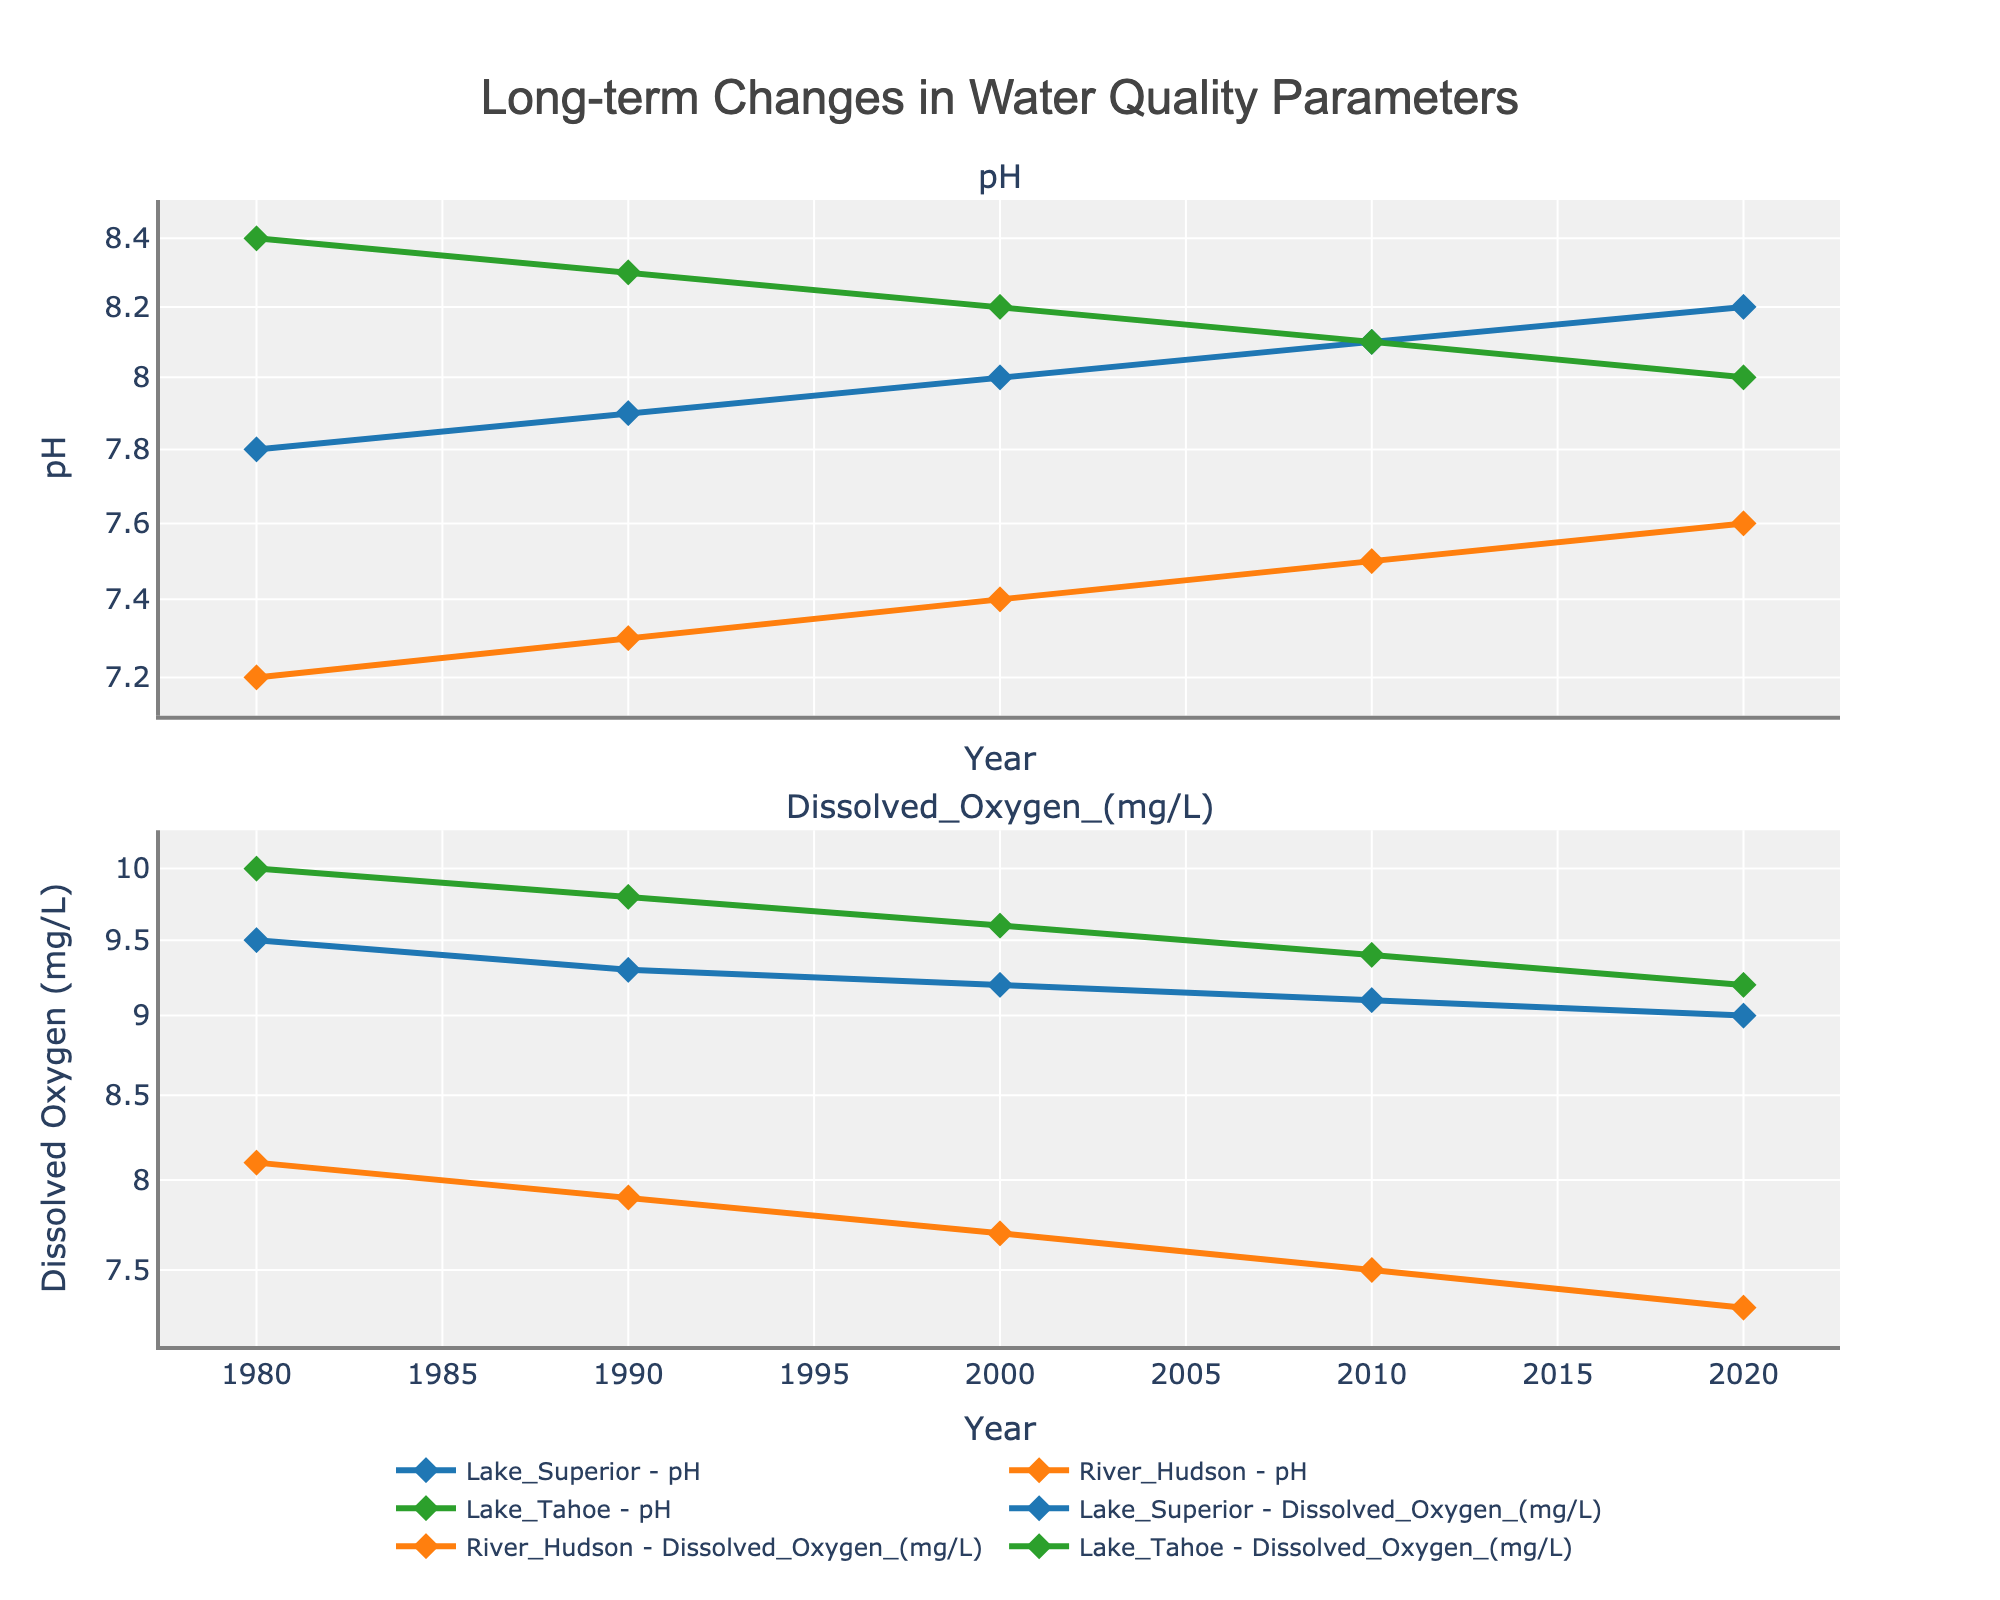What is the title of the plot? The title is located at the top of the plot and typically summarises what the plot is about. In this case, it is prominently displayed.
Answer: Long-term Changes in Water Quality Parameters How does the pH level of Lake Superior change from 1980 to 2020? By observing the line representing Lake Superior's pH levels, one can see the trend. From 1980 to 2020, the line shows a gradual increase in pH levels.
Answer: The pH level increases Which water body has the highest dissolved oxygen level in 2020? By analyzing the second subplot for dissolved oxygen levels and checking the endpoints of the lines, it's clear which one ends the highest in 2020.
Answer: Lake Tahoe Compare the change in pH for River Hudson and Lake Tahoe from 1980 to 2020. Examine the lines representing the pH levels for River Hudson and Lake Tahoe. Calculate the difference between the 2020 and 1980 values for both water bodies. Lake Tahoe's pH drops from 8.4 to 8.0, a decrease of 0.4. River Hudson's pH rises from 7.2 to 7.6, an increase of 0.4.
Answer: Lake Tahoe decreases by 0.4; River Hudson increases by 0.4 What is the trend in dissolved oxygen levels for Lake Tahoe over the years? Look at the line representing dissolved oxygen levels for Lake Tahoe in the second subplot. Notice the trend over time by following the line from left to right.
Answer: The levels decrease Between 1980 and 2000, how did River Hudson's dissolved oxygen levels change? Focus on the dissolved oxygen levels of River Hudson by checking the specific points in 1980 and 2000 on the second subplot. The levels in 1980 were 8.1 mg/L, and they decreased to 7.7 mg/L in 2000.
Answer: They decreased By 2010, what was the numerical value of Lake Superior’s pH? Refer to the first subplot and identify the data point for Lake Superior for the year 2010.
Answer: 8.1 Which had a greater change in dissolved oxygen levels between 1990 and 2020: Lake Superior or River Hudson? Calculate the difference in dissolved oxygen levels for both Lake Superior and River Hudson between 1990 and 2020. For Lake Superior, the change is 9.3 - 9.0 = 0.3 mg/L. For River Hudson, the change is 7.9 - 7.3 = 0.6 mg/L.
Answer: River Hudson What can you say about the overall trend of pH levels in most of the water bodies? Observing the pH levels in all three water bodies over the years, a clear trend is noted. Most pH levels either increase slightly or decrease marginally.
Answer: Slightly increasing or marginally decreasing Is there any year where two water bodies have the same pH or dissolved oxygen values? Scan through each year’s values for both pH and dissolved oxygen across Lake Superior, River Hudson, and Lake Tahoe. There is no instance where two water bodies have the exact same value for either parameter in a specific year according to the provided data.
Answer: No 